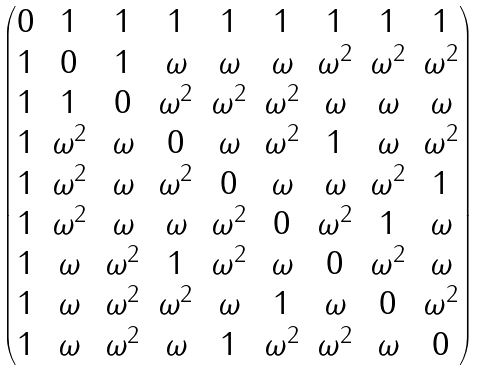Convert formula to latex. <formula><loc_0><loc_0><loc_500><loc_500>\begin{pmatrix} 0 & 1 & 1 & 1 & 1 & 1 & 1 & 1 & 1 \\ 1 & 0 & 1 & \omega & \omega & \omega & \omega ^ { 2 } & \omega ^ { 2 } & \omega ^ { 2 } \\ 1 & 1 & 0 & \omega ^ { 2 } & \omega ^ { 2 } & \omega ^ { 2 } & \omega & \omega & \omega \\ 1 & \omega ^ { 2 } & \omega & 0 & \omega & \omega ^ { 2 } & 1 & \omega & \omega ^ { 2 } \\ 1 & \omega ^ { 2 } & \omega & \omega ^ { 2 } & 0 & \omega & \omega & \omega ^ { 2 } & 1 \\ 1 & \omega ^ { 2 } & \omega & \omega & \omega ^ { 2 } & 0 & \omega ^ { 2 } & 1 & \omega \\ 1 & \omega & \omega ^ { 2 } & 1 & \omega ^ { 2 } & \omega & 0 & \omega ^ { 2 } & \omega \\ 1 & \omega & \omega ^ { 2 } & \omega ^ { 2 } & \omega & 1 & \omega & 0 & \omega ^ { 2 } \\ 1 & \omega & \omega ^ { 2 } & \omega & 1 & \omega ^ { 2 } & \omega ^ { 2 } & \omega & 0 \end{pmatrix}</formula> 